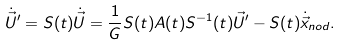<formula> <loc_0><loc_0><loc_500><loc_500>\dot { \vec { U } } ^ { \prime } & = S ( t ) \dot { \vec { U } } = \frac { 1 } { G } S ( t ) A ( t ) S ^ { - 1 } ( t ) \vec { U } ^ { \prime } - S ( t ) \dot { \vec { x } } _ { n o d } .</formula> 